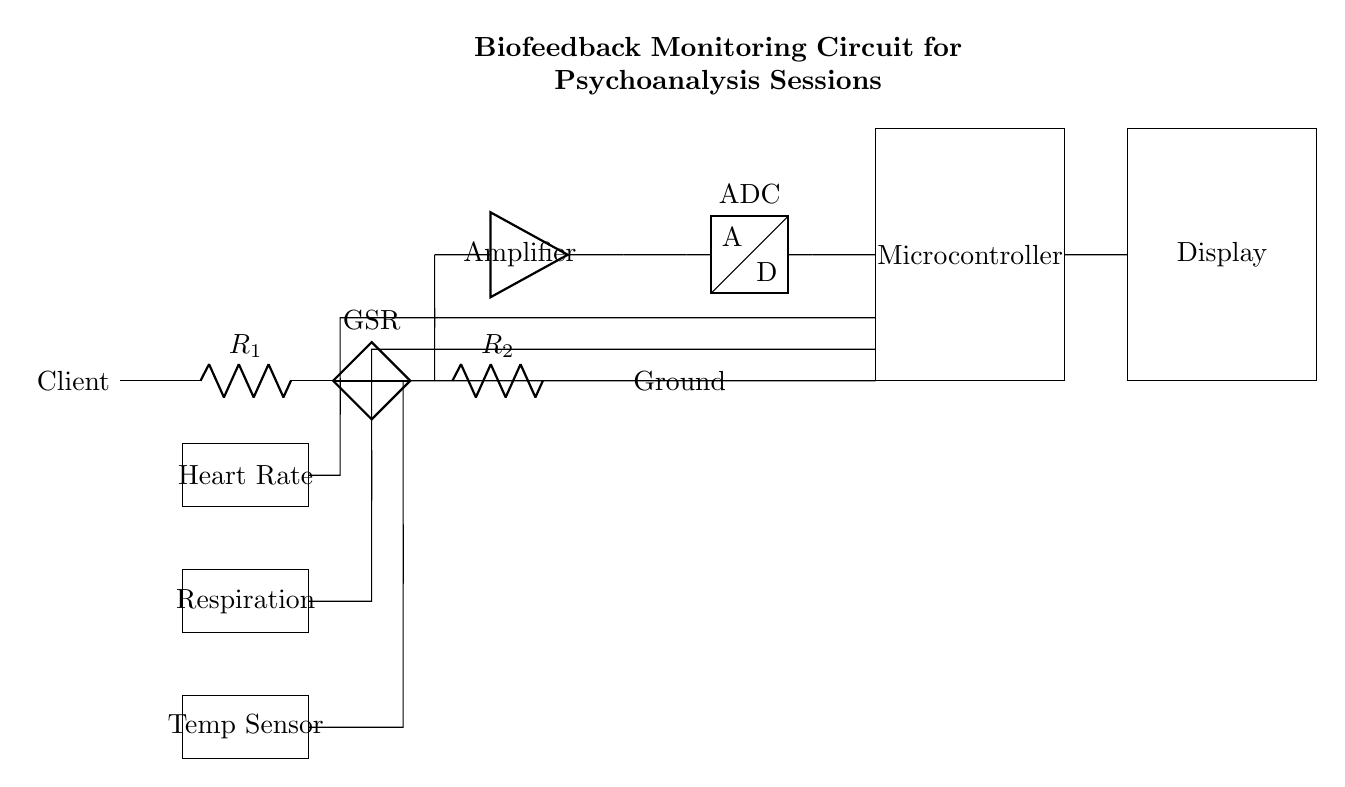What type of components are used for physiological measurement? The circuit uses resistors, voltage sources, an amplifier, an ADC, and sensors to measure physiological responses. The presence of specific components like the GSR voltage source indicates a measurement setup.
Answer: resistors, voltage sources, amplifier, ADC, sensors What does the microcontroller do in this circuit? The microcontroller processes the data collected from the sensors, which is indicated by its placement after the ADC and before the display. It is essential for analysis and interpretation of physiological data.
Answer: processes data How many sensors are included in the circuit? There are three sensors indicated by the rectangles labeled Heart Rate, Respiration, and Temp Sensor, found at the left side of the circuit.
Answer: three What is the purpose of the amplifier in the circuit? The amplifier boosts the signal received from the GSR voltage source, ensuring that the measurements are adequate for the ADC to process. This is evident from the direct connection to the ADC, indicating a need for signal amplification.
Answer: signal amplification What should be measured to assess a client's physiological response? The circuit measures heart rate, respiration, and body temperature, as indicated by the labels on the sensors connected to the microcontroller. This variety allows for a comprehensive analysis of physiological states.
Answer: heart rate, respiration, temperature What is the overall goal of this biofeedback circuit? The circuit aims to monitor physiological responses during psychoanalysis sessions, providing feedback to understand client stress and emotional states better. This is inferred from its various components designed for health monitoring.
Answer: monitor physiological responses 